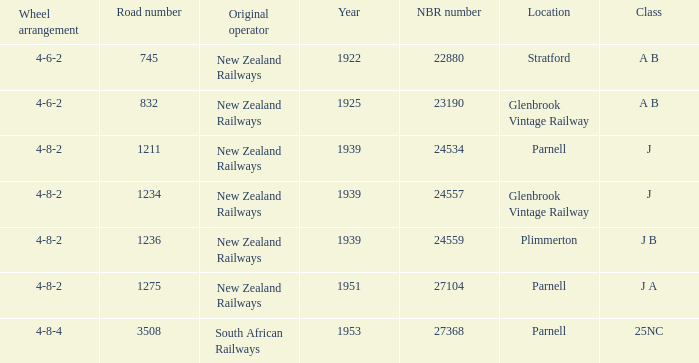I'm looking to parse the entire table for insights. Could you assist me with that? {'header': ['Wheel arrangement', 'Road number', 'Original operator', 'Year', 'NBR number', 'Location', 'Class'], 'rows': [['4-6-2', '745', 'New Zealand Railways', '1922', '22880', 'Stratford', 'A B'], ['4-6-2', '832', 'New Zealand Railways', '1925', '23190', 'Glenbrook Vintage Railway', 'A B'], ['4-8-2', '1211', 'New Zealand Railways', '1939', '24534', 'Parnell', 'J'], ['4-8-2', '1234', 'New Zealand Railways', '1939', '24557', 'Glenbrook Vintage Railway', 'J'], ['4-8-2', '1236', 'New Zealand Railways', '1939', '24559', 'Plimmerton', 'J B'], ['4-8-2', '1275', 'New Zealand Railways', '1951', '27104', 'Parnell', 'J A'], ['4-8-4', '3508', 'South African Railways', '1953', '27368', 'Parnell', '25NC']]} How many road numbers are before 1922? 0.0. 